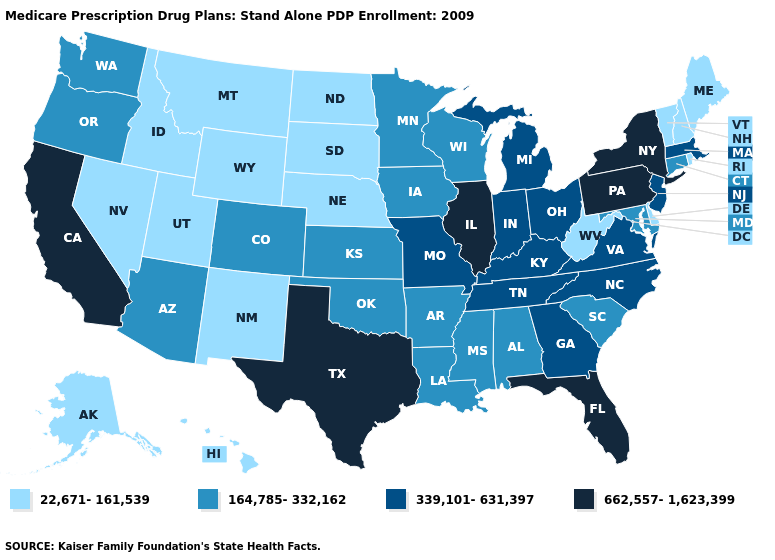Which states have the lowest value in the MidWest?
Short answer required. North Dakota, Nebraska, South Dakota. Among the states that border Nevada , which have the highest value?
Give a very brief answer. California. Does Massachusetts have the lowest value in the Northeast?
Concise answer only. No. Does Oregon have a higher value than Pennsylvania?
Short answer required. No. Name the states that have a value in the range 339,101-631,397?
Answer briefly. Georgia, Indiana, Kentucky, Massachusetts, Michigan, Missouri, North Carolina, New Jersey, Ohio, Tennessee, Virginia. Does Nevada have the same value as Vermont?
Concise answer only. Yes. How many symbols are there in the legend?
Short answer required. 4. What is the value of Nebraska?
Keep it brief. 22,671-161,539. Which states have the lowest value in the South?
Write a very short answer. Delaware, West Virginia. Name the states that have a value in the range 164,785-332,162?
Answer briefly. Alabama, Arkansas, Arizona, Colorado, Connecticut, Iowa, Kansas, Louisiana, Maryland, Minnesota, Mississippi, Oklahoma, Oregon, South Carolina, Washington, Wisconsin. Which states hav the highest value in the South?
Concise answer only. Florida, Texas. Among the states that border New Hampshire , does Massachusetts have the lowest value?
Keep it brief. No. Name the states that have a value in the range 662,557-1,623,399?
Keep it brief. California, Florida, Illinois, New York, Pennsylvania, Texas. Name the states that have a value in the range 662,557-1,623,399?
Keep it brief. California, Florida, Illinois, New York, Pennsylvania, Texas. Which states hav the highest value in the MidWest?
Be succinct. Illinois. 